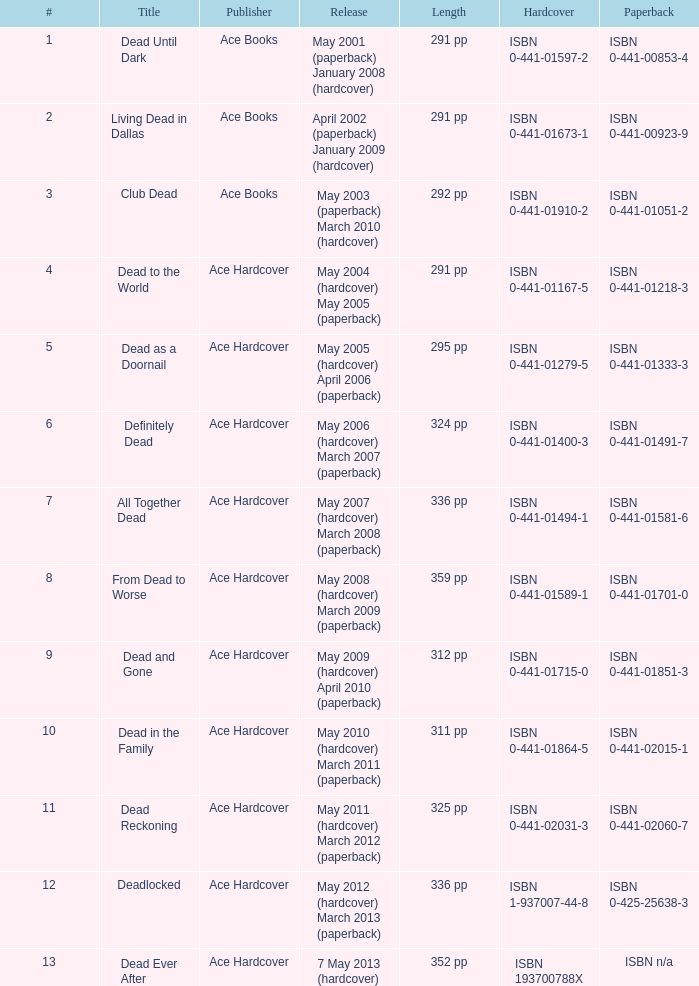What is the international standard book number (isbn) for "dead as a doornail"? ISBN 0-441-01333-3. 